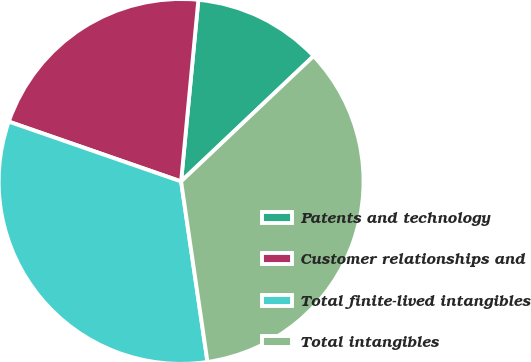Convert chart. <chart><loc_0><loc_0><loc_500><loc_500><pie_chart><fcel>Patents and technology<fcel>Customer relationships and<fcel>Total finite-lived intangibles<fcel>Total intangibles<nl><fcel>11.43%<fcel>21.19%<fcel>32.63%<fcel>34.75%<nl></chart> 